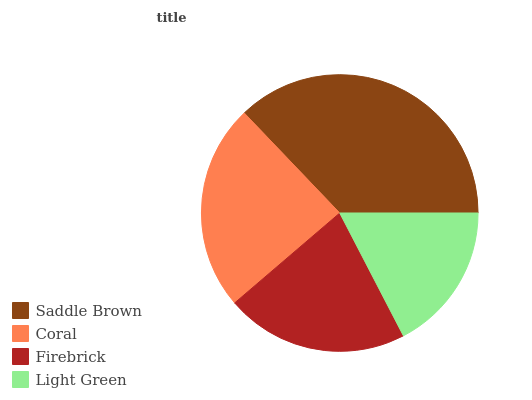Is Light Green the minimum?
Answer yes or no. Yes. Is Saddle Brown the maximum?
Answer yes or no. Yes. Is Coral the minimum?
Answer yes or no. No. Is Coral the maximum?
Answer yes or no. No. Is Saddle Brown greater than Coral?
Answer yes or no. Yes. Is Coral less than Saddle Brown?
Answer yes or no. Yes. Is Coral greater than Saddle Brown?
Answer yes or no. No. Is Saddle Brown less than Coral?
Answer yes or no. No. Is Coral the high median?
Answer yes or no. Yes. Is Firebrick the low median?
Answer yes or no. Yes. Is Light Green the high median?
Answer yes or no. No. Is Saddle Brown the low median?
Answer yes or no. No. 